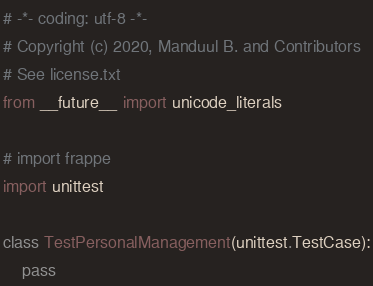<code> <loc_0><loc_0><loc_500><loc_500><_Python_># -*- coding: utf-8 -*-
# Copyright (c) 2020, Manduul B. and Contributors
# See license.txt
from __future__ import unicode_literals

# import frappe
import unittest

class TestPersonalManagement(unittest.TestCase):
	pass
</code> 